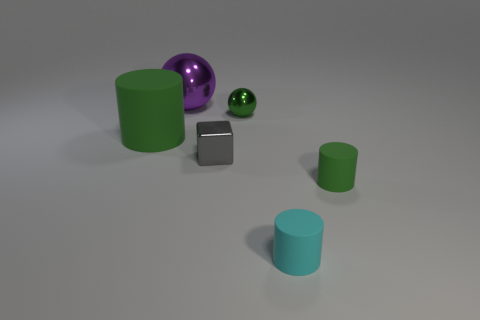Add 2 small metallic things. How many objects exist? 8 Subtract all blocks. How many objects are left? 5 Add 1 small balls. How many small balls exist? 2 Subtract 1 gray cubes. How many objects are left? 5 Subtract all small green rubber cylinders. Subtract all tiny gray blocks. How many objects are left? 4 Add 2 small gray shiny cubes. How many small gray shiny cubes are left? 3 